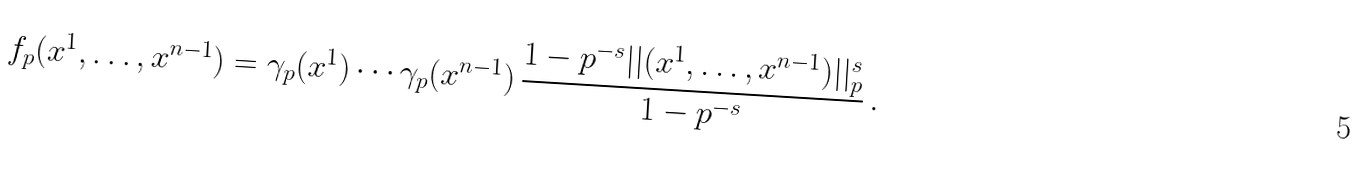Convert formula to latex. <formula><loc_0><loc_0><loc_500><loc_500>f _ { p } ( x ^ { 1 } , \dots , x ^ { n - 1 } ) = \gamma _ { p } ( x ^ { 1 } ) \cdots \gamma _ { p } ( x ^ { n - 1 } ) \, \frac { 1 - p ^ { - s } | | ( x ^ { 1 } , \dots , x ^ { n - 1 } ) | | _ { p } ^ { s } } { 1 - p ^ { - s } } \, .</formula> 